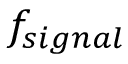Convert formula to latex. <formula><loc_0><loc_0><loc_500><loc_500>f _ { s i g n a l }</formula> 